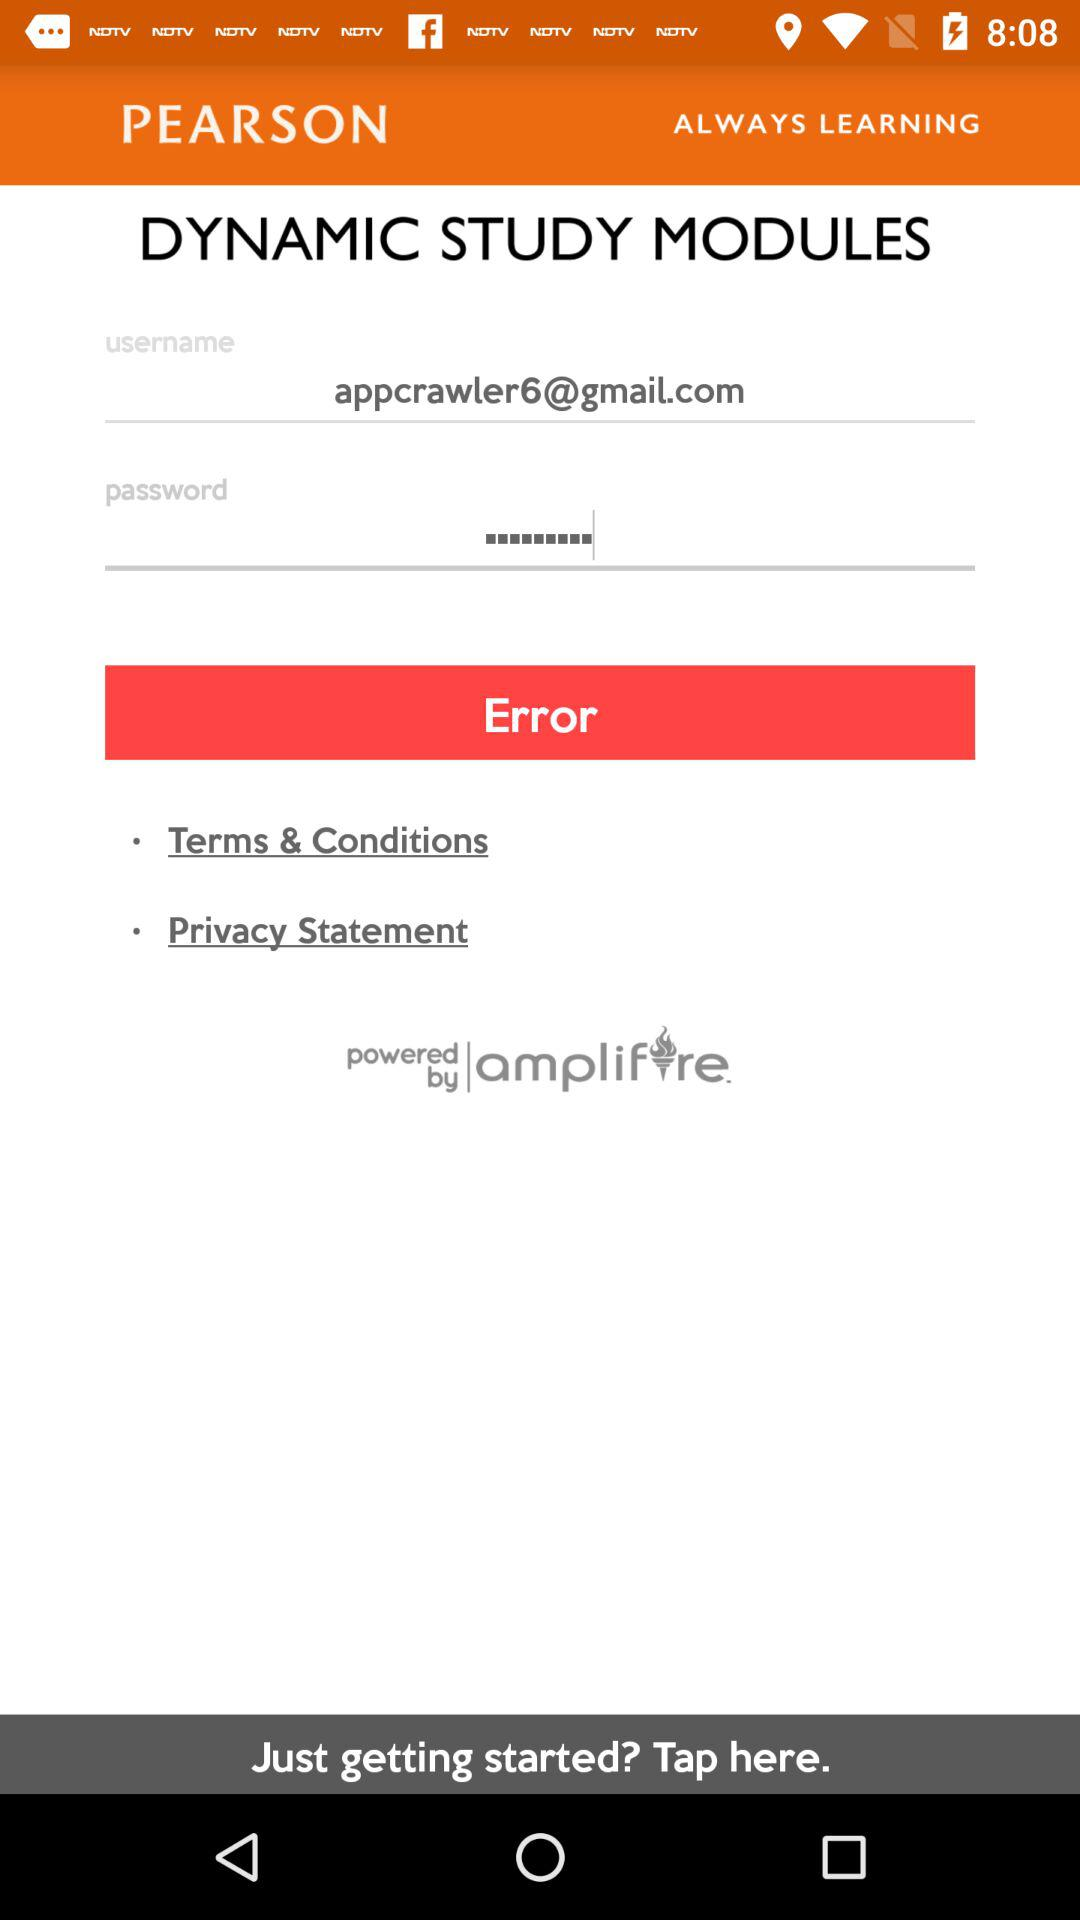Is the user just getting started?
When the provided information is insufficient, respond with <no answer>. <no answer> 